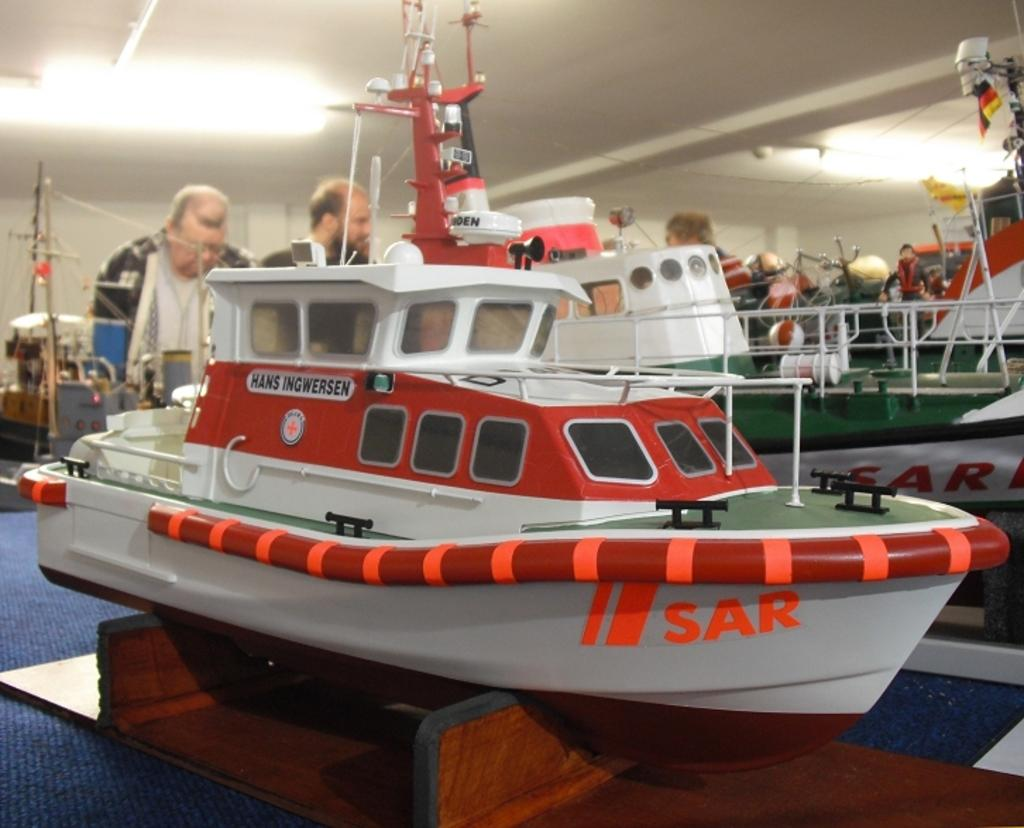What is the main subject in the foreground of the image? There is a catalog of various ships and boats in the foreground of the image. What can be seen in the background of the image? There are lights, a wall, and people in the background of the image. What type of object is at the bottom of the image? There is a wooden object at the bottom of the image. What type of mitten is being used to defuse the bomb in the image? There is no mitten or bomb present in the image. Who is the partner of the person holding the wooden object in the image? There is no indication of a partner or any interaction between people in the image. 